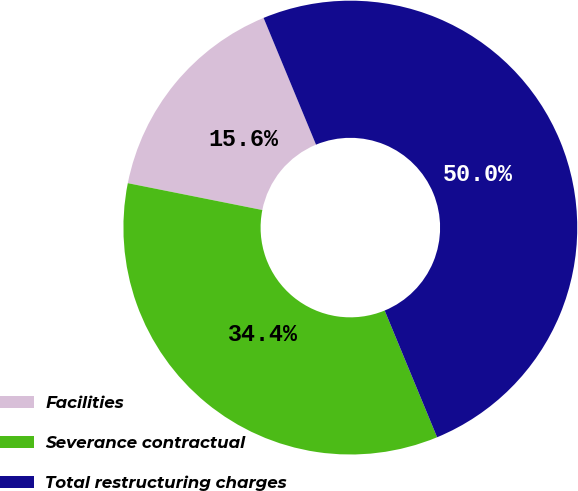Convert chart. <chart><loc_0><loc_0><loc_500><loc_500><pie_chart><fcel>Facilities<fcel>Severance contractual<fcel>Total restructuring charges<nl><fcel>15.62%<fcel>34.38%<fcel>50.0%<nl></chart> 